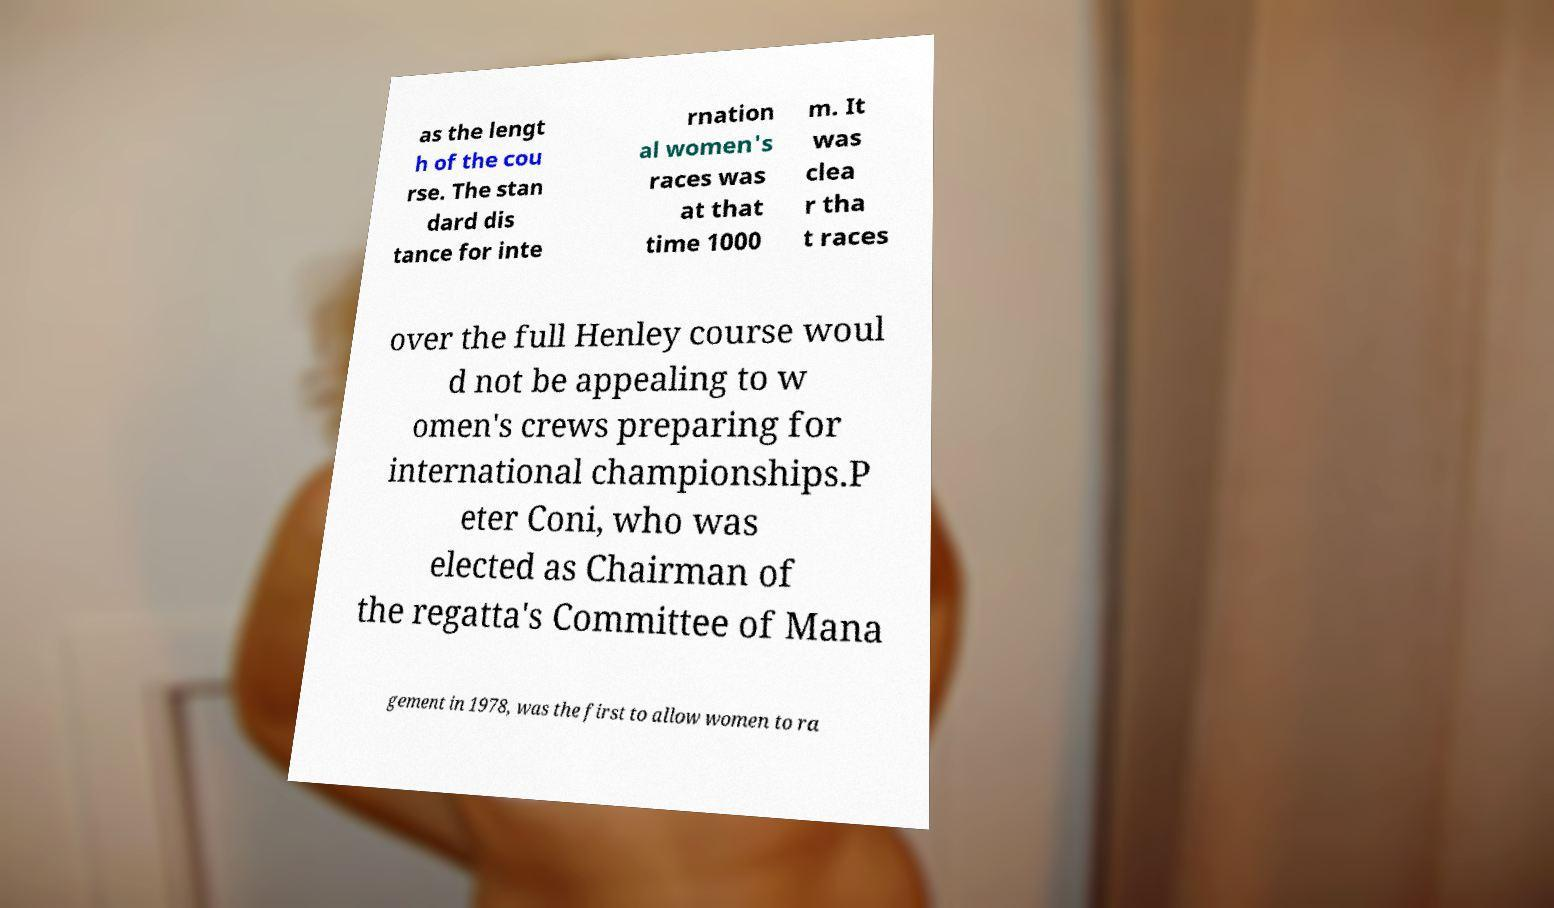Can you accurately transcribe the text from the provided image for me? as the lengt h of the cou rse. The stan dard dis tance for inte rnation al women's races was at that time 1000 m. It was clea r tha t races over the full Henley course woul d not be appealing to w omen's crews preparing for international championships.P eter Coni, who was elected as Chairman of the regatta's Committee of Mana gement in 1978, was the first to allow women to ra 